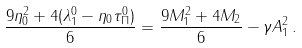Convert formula to latex. <formula><loc_0><loc_0><loc_500><loc_500>\frac { 9 \eta _ { 0 } ^ { 2 } + 4 ( \lambda _ { 1 } ^ { 0 } - \eta _ { 0 } \tau _ { \Pi } ^ { 0 } ) } 6 = \frac { 9 M _ { 1 } ^ { 2 } + 4 M _ { 2 } } 6 - \gamma A _ { 1 } ^ { 2 } \, .</formula> 